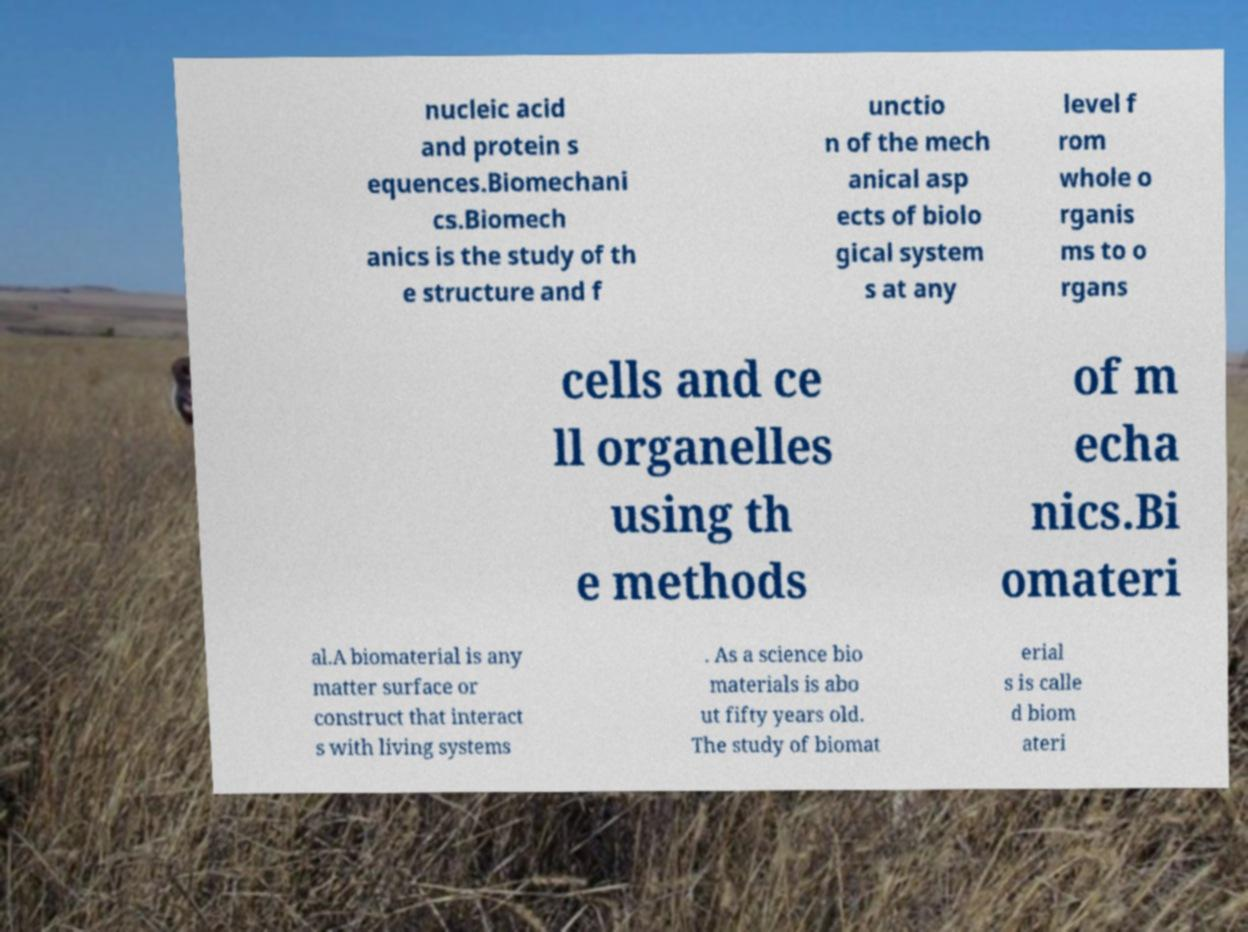Can you read and provide the text displayed in the image?This photo seems to have some interesting text. Can you extract and type it out for me? nucleic acid and protein s equences.Biomechani cs.Biomech anics is the study of th e structure and f unctio n of the mech anical asp ects of biolo gical system s at any level f rom whole o rganis ms to o rgans cells and ce ll organelles using th e methods of m echa nics.Bi omateri al.A biomaterial is any matter surface or construct that interact s with living systems . As a science bio materials is abo ut fifty years old. The study of biomat erial s is calle d biom ateri 